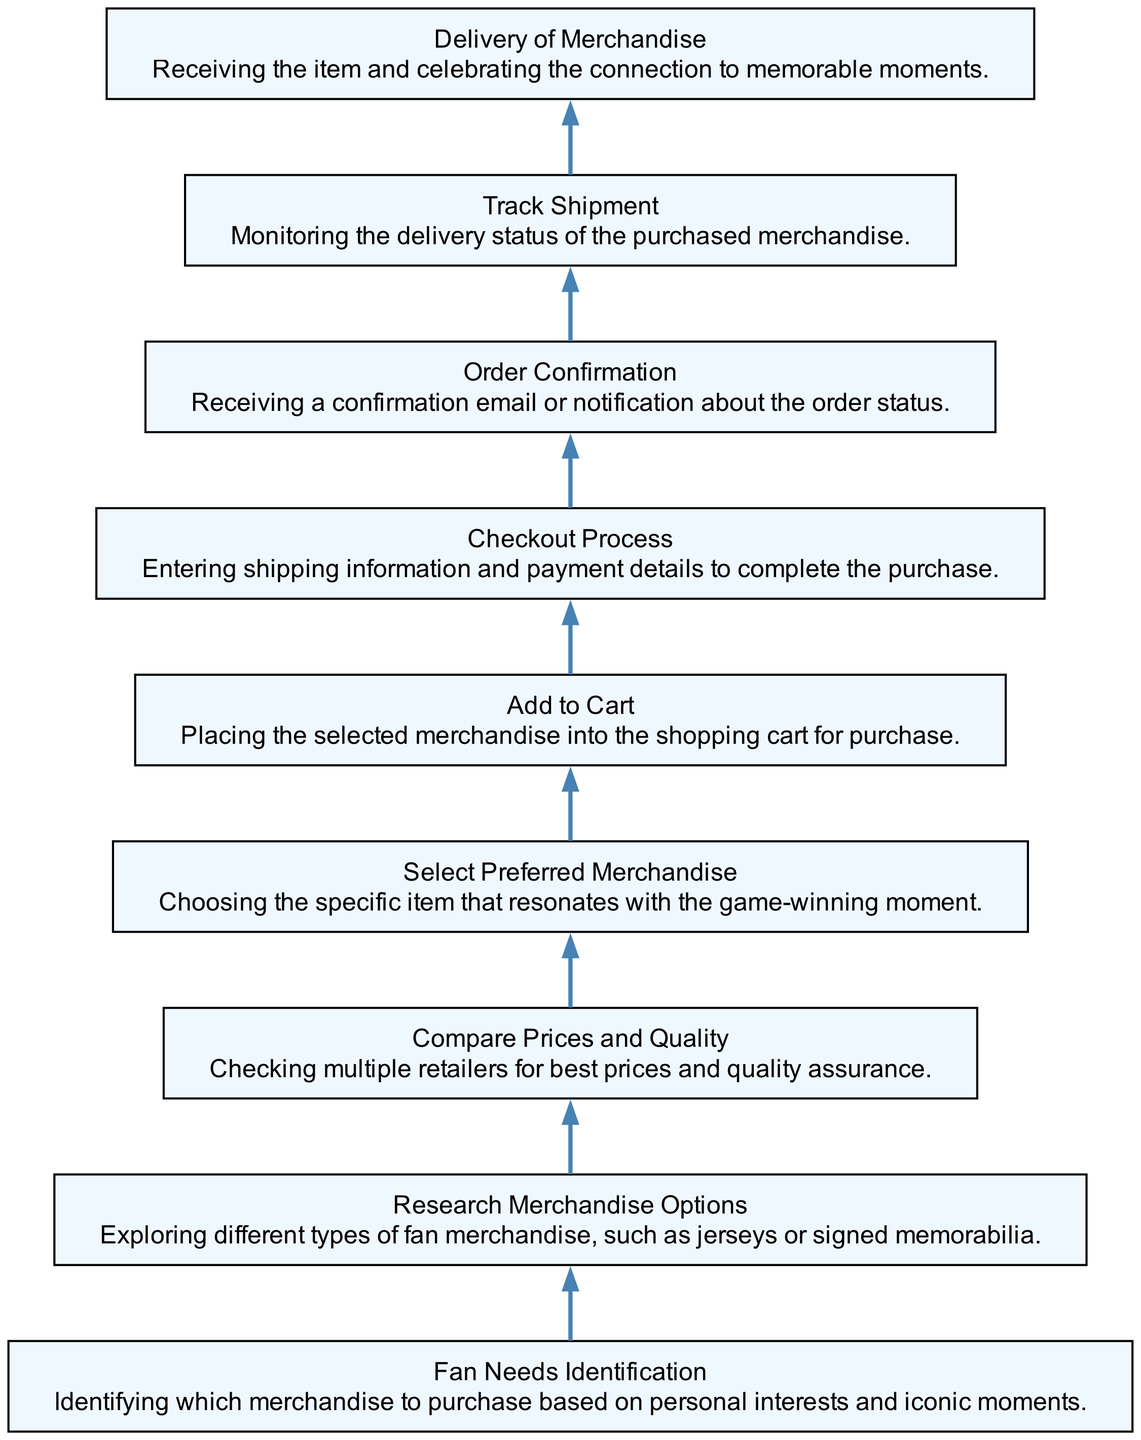What is the first step in the purchasing journey? The first node in the diagram indicates the initial step, which is "Fan Needs Identification." This is the entry point into the purchasing journey.
Answer: Fan Needs Identification How many nodes are there in total? By counting each unique step represented in the diagram, there are nine nodes depicting different stages of the purchasing journey.
Answer: Nine Which node comes after "Select Preferred Merchandise"? In the flow, "Add to Cart" directly follows "Select Preferred Merchandise," indicating the next action taken by the fan after making their choice.
Answer: Add to Cart What is the last step in the purchasing journey? The diagram shows that "Delivery of Merchandise" is the final node, marking the completion of the purchasing journey.
Answer: Delivery of Merchandise How many edges connect all the nodes? Each step is sequentially interconnected by edges, resulting in a total of eight edges joining the nine nodes together, indicating the flow from one step to the next.
Answer: Eight What does "Research Merchandise Options" involve? The description associated with this node clarifies that it entails exploring various merchandise types, which may include jerseys or signed memorabilia, as part of the fan's research.
Answer: Exploring different types of fan merchandise Which step requires entering payment details? The step labeled "Checkout Process" is where entering shipping information and payment details takes place, being a critical part of finalizing the purchase.
Answer: Checkout Process What is the purpose of the "Track Shipment" node? This node serves the purpose of monitoring the delivery status of the purchased merchandise, providing updates on the shipping process to the fan.
Answer: Monitoring the delivery status What is the significance of "Order Confirmation"? It signifies that the fan has successfully completed the order process, as indicated by receiving an email or notification about the order status, confirming the purchase.
Answer: Receiving a confirmation email or notification 